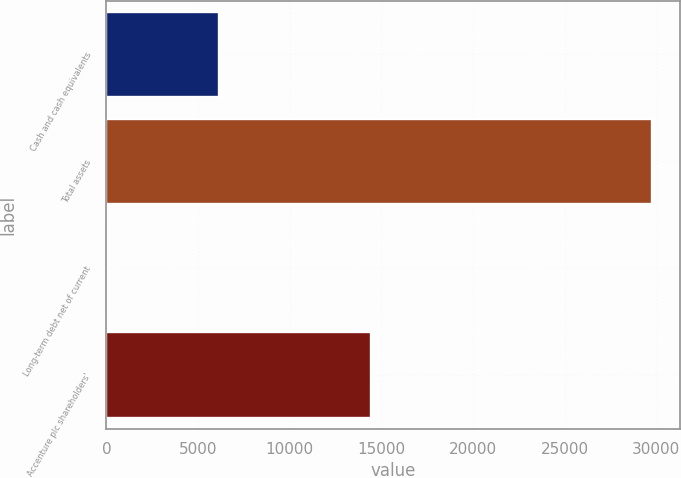<chart> <loc_0><loc_0><loc_500><loc_500><bar_chart><fcel>Cash and cash equivalents<fcel>Total assets<fcel>Long-term debt net of current<fcel>Accenture plc shareholders'<nl><fcel>6127<fcel>29790<fcel>16<fcel>14409<nl></chart> 